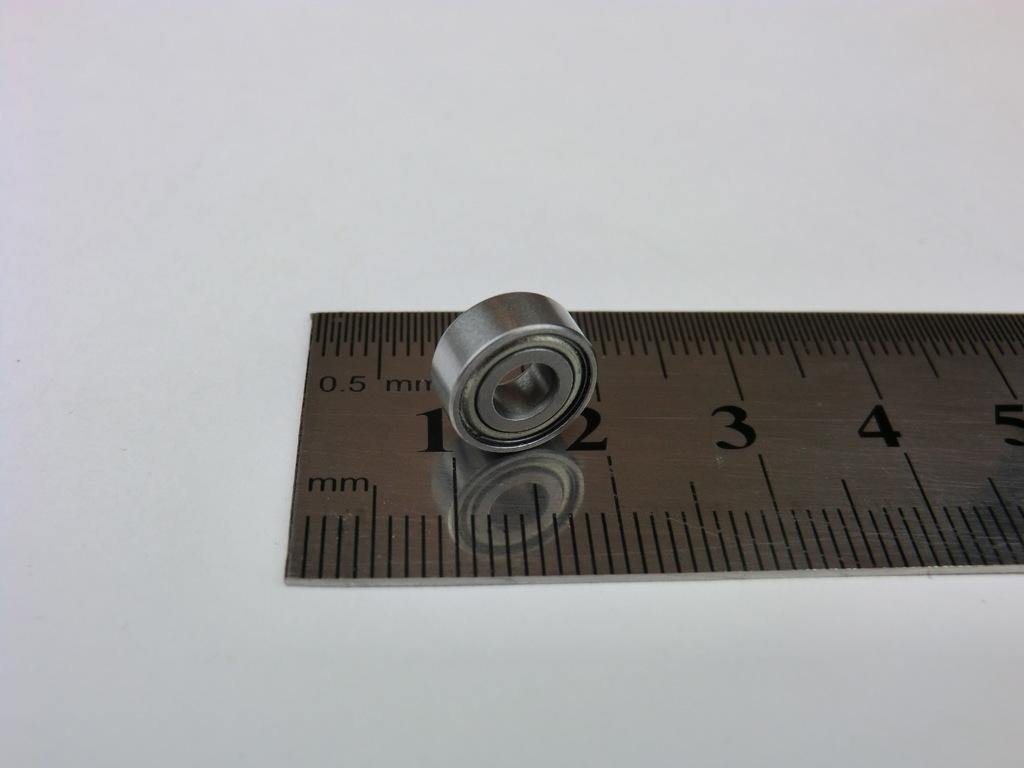Provide a one-sentence caption for the provided image. A metal ruler has 0.5 mm on the upper left corner. 